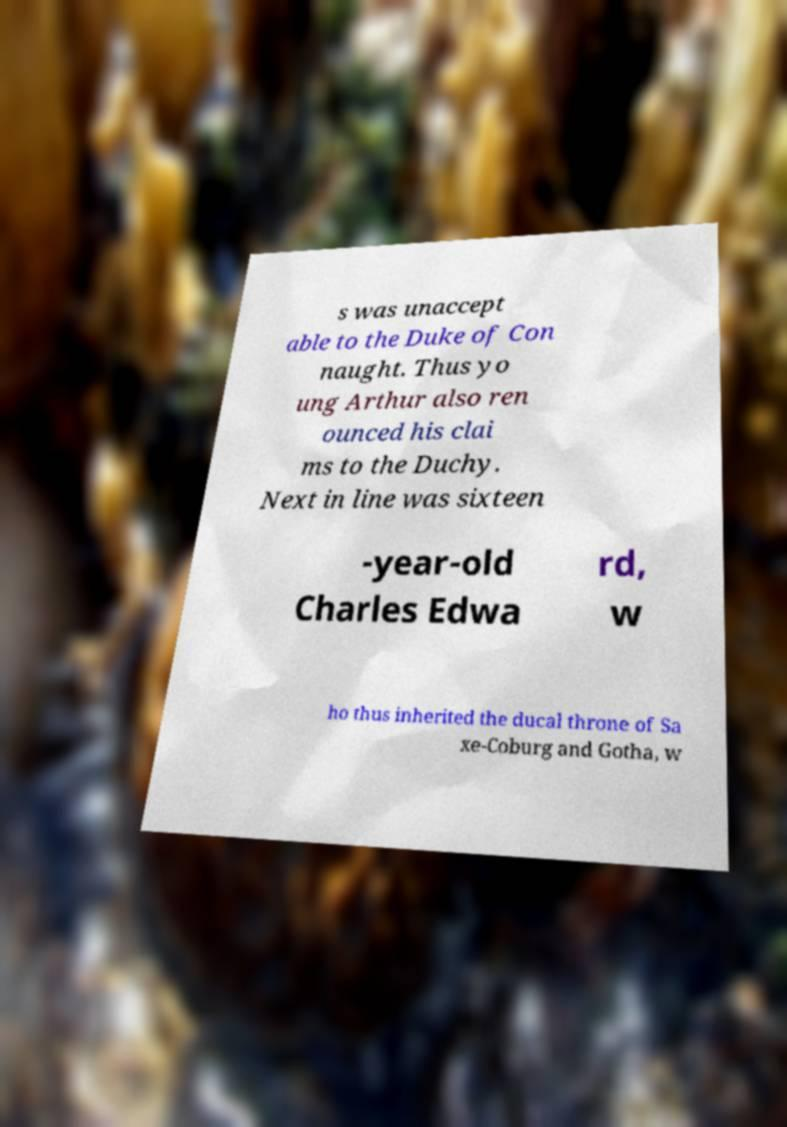Could you assist in decoding the text presented in this image and type it out clearly? s was unaccept able to the Duke of Con naught. Thus yo ung Arthur also ren ounced his clai ms to the Duchy. Next in line was sixteen -year-old Charles Edwa rd, w ho thus inherited the ducal throne of Sa xe-Coburg and Gotha, w 